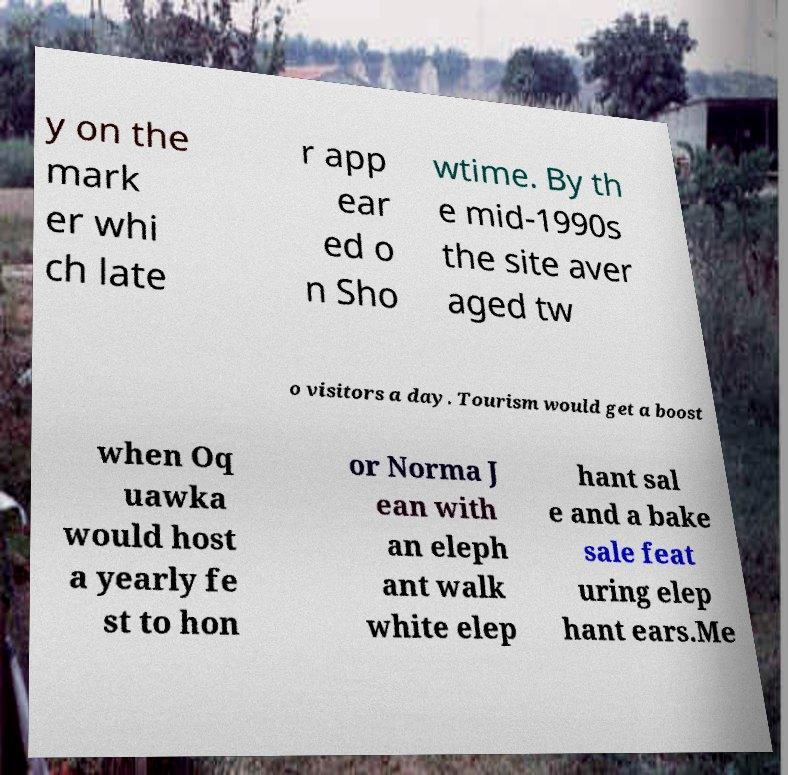What messages or text are displayed in this image? I need them in a readable, typed format. y on the mark er whi ch late r app ear ed o n Sho wtime. By th e mid-1990s the site aver aged tw o visitors a day. Tourism would get a boost when Oq uawka would host a yearly fe st to hon or Norma J ean with an eleph ant walk white elep hant sal e and a bake sale feat uring elep hant ears.Me 